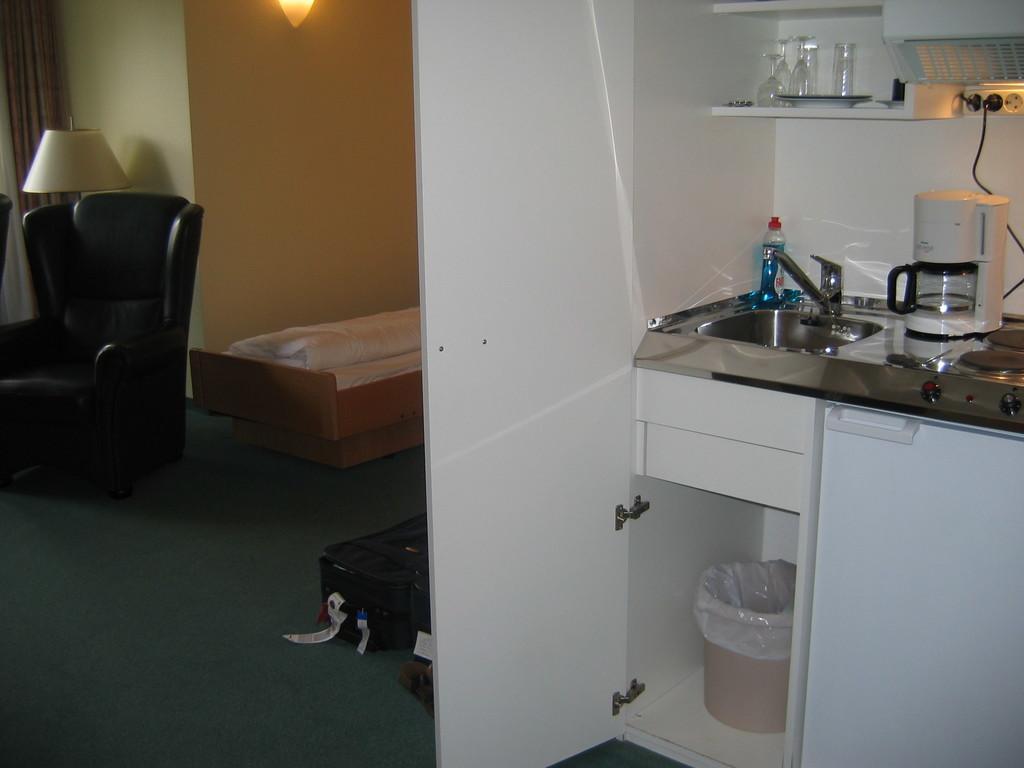Can you describe this image briefly? In this picture we can see a dustbin in the rack and at the top of the rack there is a sink with tap. On the right side of the sink there is a machine and on the left side of the sink there is a bottle. At the top of the sink there are glasses and plates in the rack. On the right side of the machine, there is a stove and on the left side of the sink there is a chair, lamp, trolley bag and an object. Behind the chair there is a wall with a light and a curtain. 